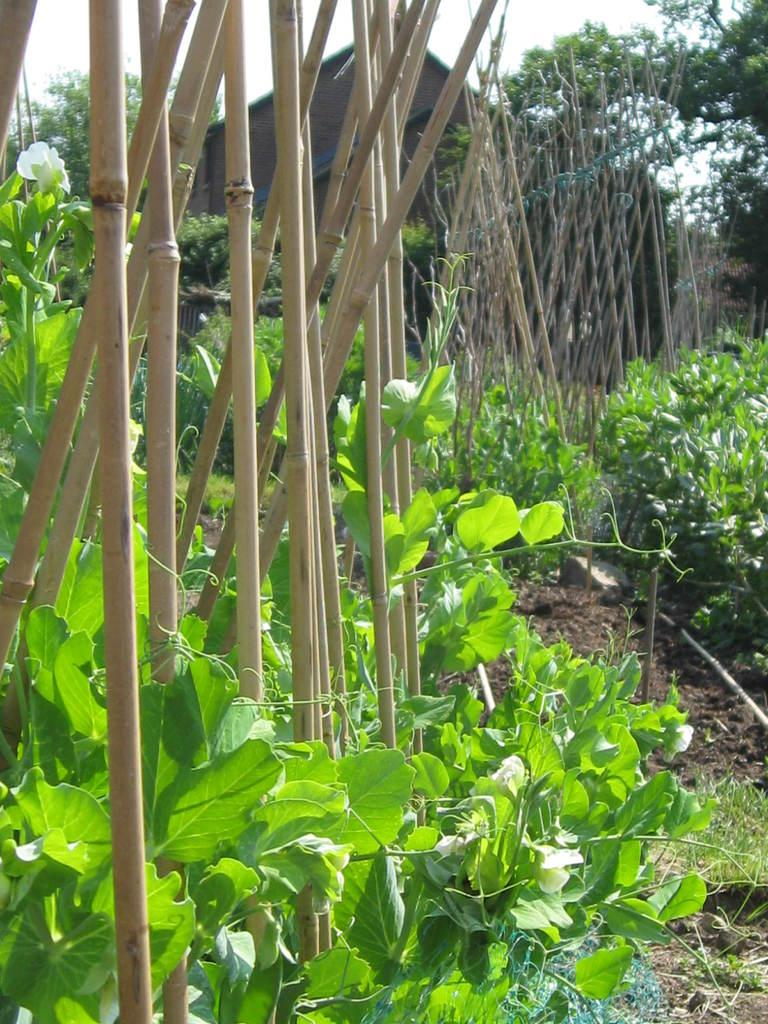What type of living organisms can be seen in the image? Plants can be seen in the image. What type of material is the fence in the image made of? The fence in the image is made of wood. What can be seen in the background of the image? There is a house and trees in the background of the image. What type of can is visible in the image? There is no can present in the image. Is there a battle taking place in the image? There is no battle depicted in the image. 